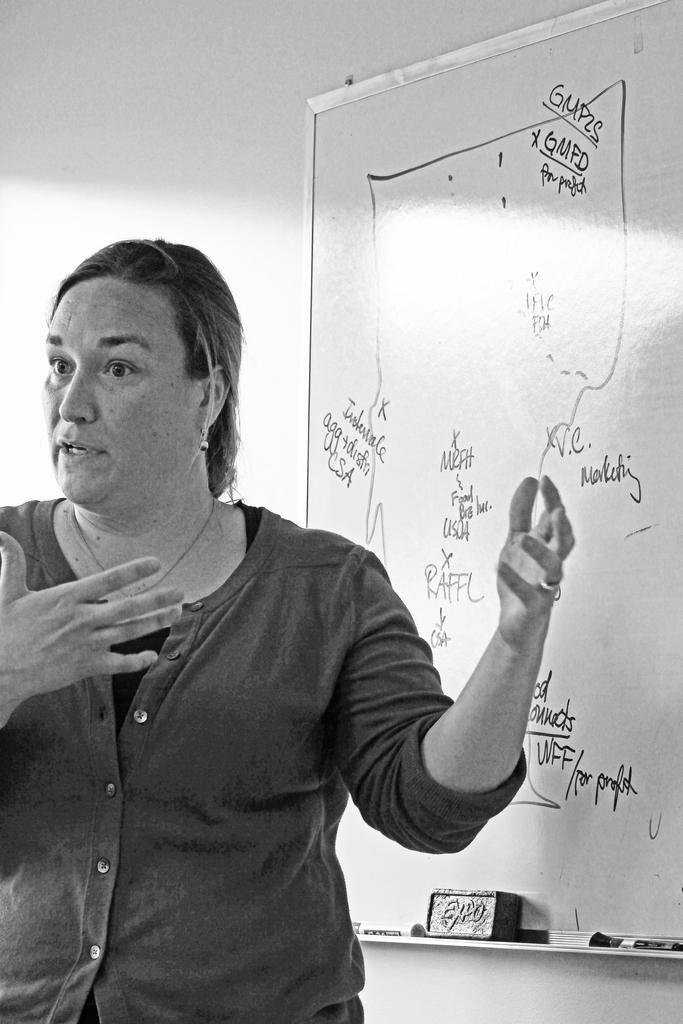Can you describe this image briefly? In this image, I can see a woman explaining behind her i can see a white board there is something written on it and a wall. 